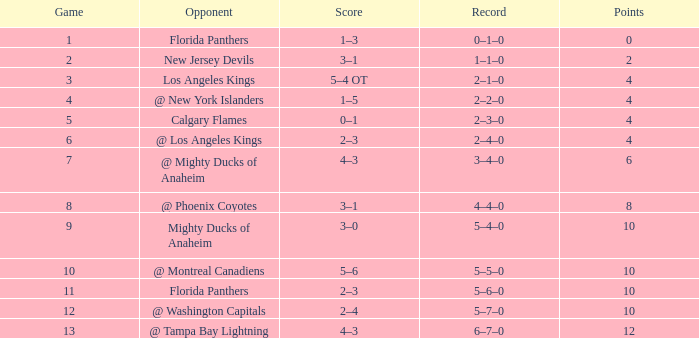What team has a score of 11 5–6–0. 